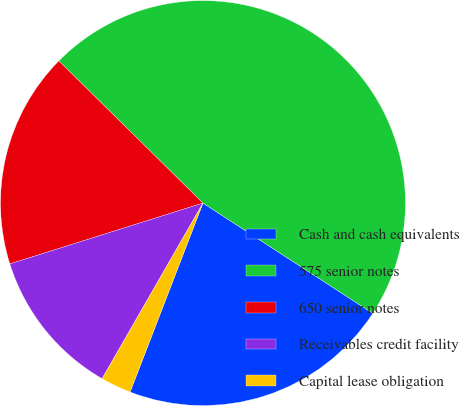Convert chart to OTSL. <chart><loc_0><loc_0><loc_500><loc_500><pie_chart><fcel>Cash and cash equivalents<fcel>575 senior notes<fcel>650 senior notes<fcel>Receivables credit facility<fcel>Capital lease obligation<nl><fcel>21.69%<fcel>46.77%<fcel>17.25%<fcel>11.84%<fcel>2.44%<nl></chart> 